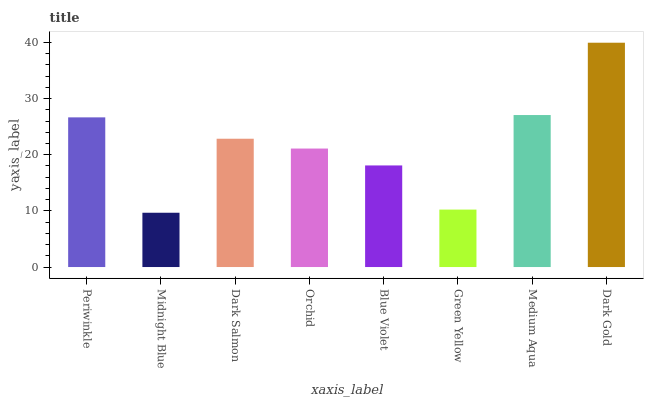Is Midnight Blue the minimum?
Answer yes or no. Yes. Is Dark Gold the maximum?
Answer yes or no. Yes. Is Dark Salmon the minimum?
Answer yes or no. No. Is Dark Salmon the maximum?
Answer yes or no. No. Is Dark Salmon greater than Midnight Blue?
Answer yes or no. Yes. Is Midnight Blue less than Dark Salmon?
Answer yes or no. Yes. Is Midnight Blue greater than Dark Salmon?
Answer yes or no. No. Is Dark Salmon less than Midnight Blue?
Answer yes or no. No. Is Dark Salmon the high median?
Answer yes or no. Yes. Is Orchid the low median?
Answer yes or no. Yes. Is Midnight Blue the high median?
Answer yes or no. No. Is Dark Salmon the low median?
Answer yes or no. No. 